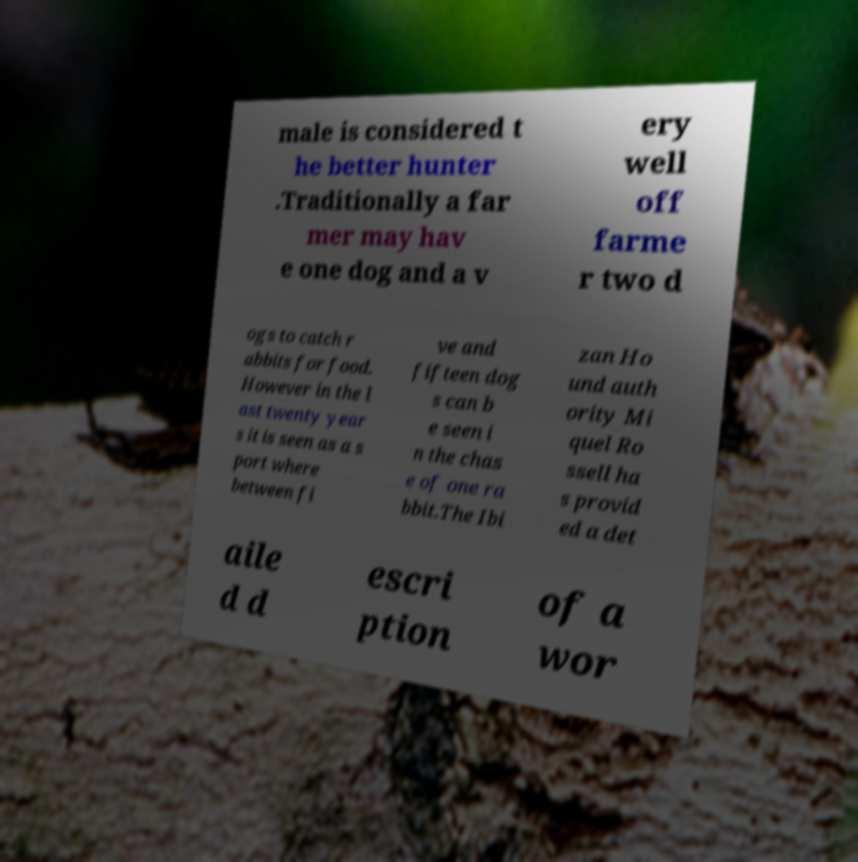What messages or text are displayed in this image? I need them in a readable, typed format. male is considered t he better hunter .Traditionally a far mer may hav e one dog and a v ery well off farme r two d ogs to catch r abbits for food. However in the l ast twenty year s it is seen as a s port where between fi ve and fifteen dog s can b e seen i n the chas e of one ra bbit.The Ibi zan Ho und auth ority Mi quel Ro ssell ha s provid ed a det aile d d escri ption of a wor 